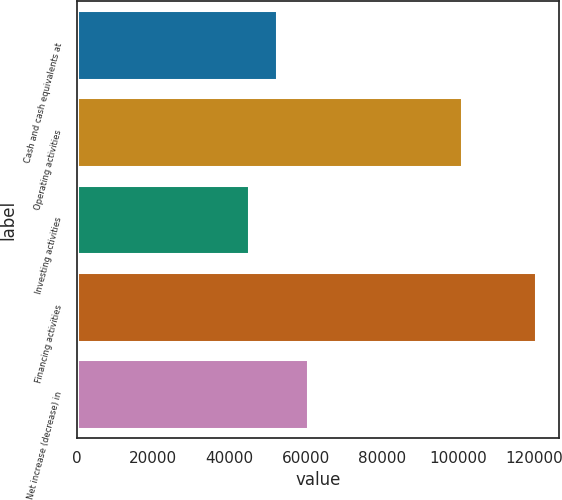Convert chart to OTSL. <chart><loc_0><loc_0><loc_500><loc_500><bar_chart><fcel>Cash and cash equivalents at<fcel>Operating activities<fcel>Investing activities<fcel>Financing activities<fcel>Net increase (decrease) in<nl><fcel>52536<fcel>100817<fcel>45065<fcel>120290<fcel>60623<nl></chart> 